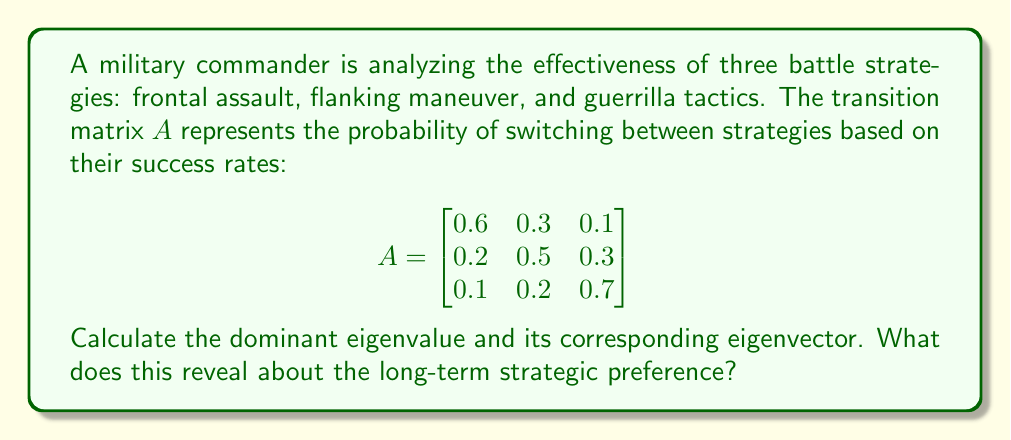Teach me how to tackle this problem. 1) First, we need to find the eigenvalues by solving the characteristic equation:
   $det(A - \lambda I) = 0$

2) Expanding this:
   $$(0.6-\lambda)(0.5-\lambda)(0.7-\lambda) - 0.3 \cdot 0.3 \cdot 0.1 - 0.1 \cdot 0.2 \cdot 0.2 \\
   - (0.6-\lambda) \cdot 0.2 \cdot 0.2 - (0.5-\lambda) \cdot 0.1 \cdot 0.1 - (0.7-\lambda) \cdot 0.3 \cdot 0.2 = 0$$

3) Simplifying:
   $-\lambda^3 + 1.8\lambda^2 - 1.07\lambda + 0.21 = 0$

4) Solving this cubic equation (using a calculator or computer algebra system), we get:
   $\lambda_1 \approx 1$, $\lambda_2 \approx 0.5$, $\lambda_3 \approx 0.3$

5) The dominant eigenvalue is $\lambda_1 = 1$

6) Now, we find the eigenvector $v$ corresponding to $\lambda_1 = 1$:
   $(A - I)v = 0$

7) This gives us the system:
   $$\begin{bmatrix}
   -0.4 & 0.3 & 0.1 \\
   0.2 & -0.5 & 0.3 \\
   0.1 & 0.2 & -0.3
   \end{bmatrix} \begin{bmatrix} v_1 \\ v_2 \\ v_3 \end{bmatrix} = \begin{bmatrix} 0 \\ 0 \\ 0 \end{bmatrix}$$

8) Solving this system (and normalizing), we get:
   $v \approx [0.4444, 0.3333, 0.2222]^T$

9) This eigenvector represents the steady-state distribution of strategy usage. It indicates that in the long term, approximately 44.44% of the time will be spent on frontal assault, 33.33% on flanking maneuver, and 22.22% on guerrilla tactics.
Answer: Dominant eigenvalue: 1; Eigenvector: [0.4444, 0.3333, 0.2222]. Long-term preference: 44.44% frontal assault, 33.33% flanking, 22.22% guerrilla. 